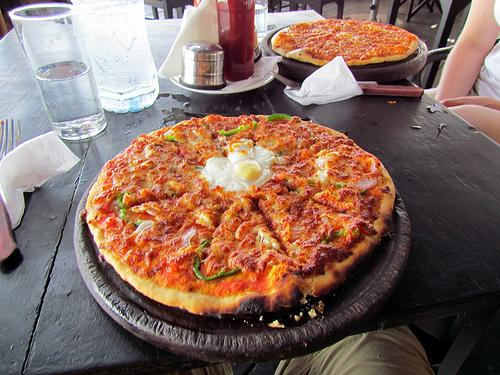List the cutlery items available in the image. There is a silver fork facing upwards, and a piece of silverware with a brown handle on the table. Briefly describe the setting of the image, including the table and the main food item. The image shows a large pizza pie with a fried egg on top, placed on a brown table with a variety of other items. Mention the most interesting aspect of the food on the table. The most intriguing part is the fried egg placed in the middle of the pizza, giving it a unique twist. Mention the primary food item on the table and its standout feature. A large pizza with a fried egg in the middle is the main dish on the dark brown wooden table. Create a sentence focusing on the various captions of the pizza. The pizza is described as tasty, with a crust, having multiple pieces, and being visible in several instances. Narrate the scene focusing on the water items in the image. A tall glass, half full of water, and a water bottle with water are present next to a pitcher of water on the table. Write a statement about the state of glass and the liquid it contains. The glass in the image is transparent and contains water up to its halfway point. Discuss the additional condiments and napkins on the table. The table has a ketchup bottle, silver and red bottles on a plate, a used white napkin, and another white napkin. Describe the image, focusing on the object with the wooden appearance. A pizza is placed atop a brown tray on a dark brown wooden table, with wooden handled silverware nearby. Write about the person visible in the image and their position. A person's arm and leg can be seen off to the side, possibly sitting at the table with the pizza. 